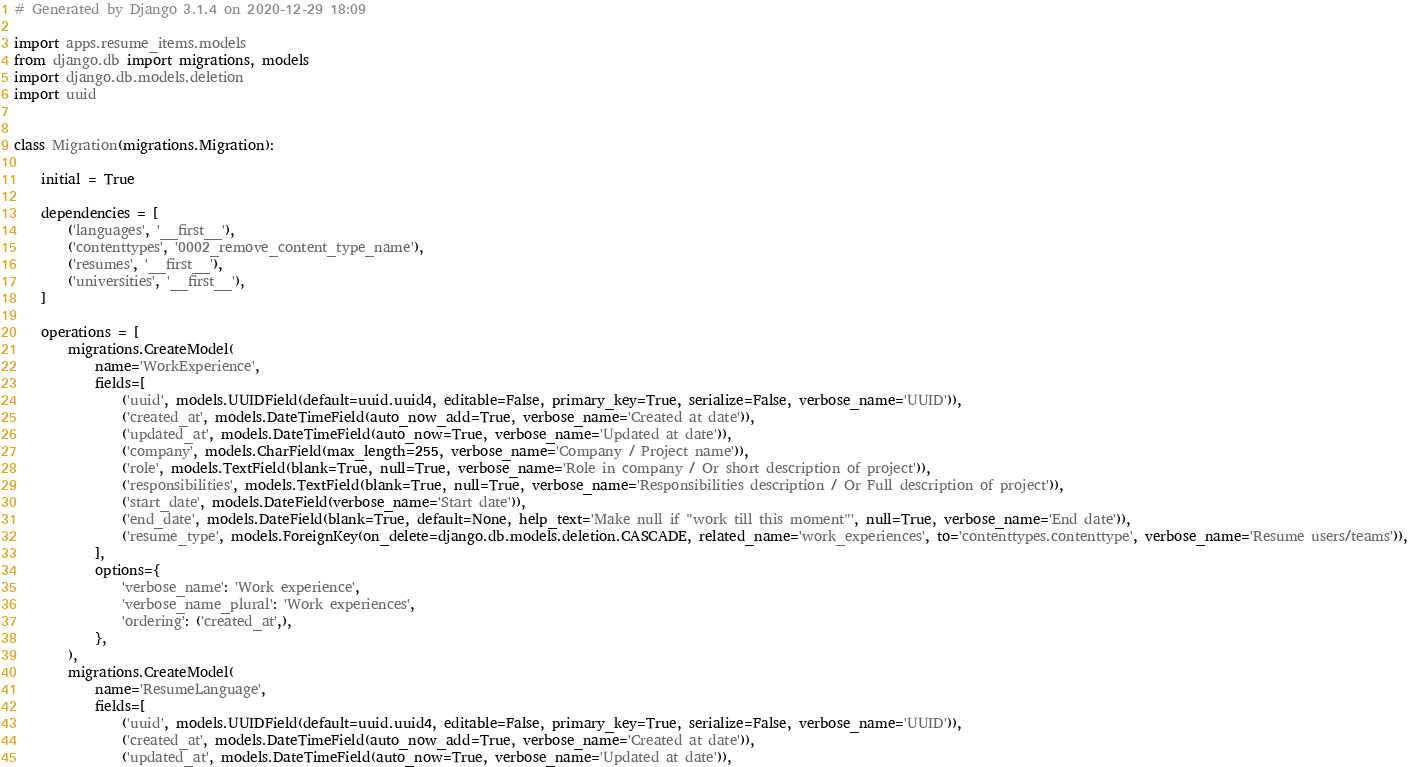Convert code to text. <code><loc_0><loc_0><loc_500><loc_500><_Python_># Generated by Django 3.1.4 on 2020-12-29 18:09

import apps.resume_items.models
from django.db import migrations, models
import django.db.models.deletion
import uuid


class Migration(migrations.Migration):

    initial = True

    dependencies = [
        ('languages', '__first__'),
        ('contenttypes', '0002_remove_content_type_name'),
        ('resumes', '__first__'),
        ('universities', '__first__'),
    ]

    operations = [
        migrations.CreateModel(
            name='WorkExperience',
            fields=[
                ('uuid', models.UUIDField(default=uuid.uuid4, editable=False, primary_key=True, serialize=False, verbose_name='UUID')),
                ('created_at', models.DateTimeField(auto_now_add=True, verbose_name='Created at date')),
                ('updated_at', models.DateTimeField(auto_now=True, verbose_name='Updated at date')),
                ('company', models.CharField(max_length=255, verbose_name='Company / Project name')),
                ('role', models.TextField(blank=True, null=True, verbose_name='Role in company / Or short description of project')),
                ('responsibilities', models.TextField(blank=True, null=True, verbose_name='Responsibilities description / Or Full description of project')),
                ('start_date', models.DateField(verbose_name='Start date')),
                ('end_date', models.DateField(blank=True, default=None, help_text='Make null if "work till this moment"', null=True, verbose_name='End date')),
                ('resume_type', models.ForeignKey(on_delete=django.db.models.deletion.CASCADE, related_name='work_experiences', to='contenttypes.contenttype', verbose_name='Resume users/teams')),
            ],
            options={
                'verbose_name': 'Work experience',
                'verbose_name_plural': 'Work experiences',
                'ordering': ('created_at',),
            },
        ),
        migrations.CreateModel(
            name='ResumeLanguage',
            fields=[
                ('uuid', models.UUIDField(default=uuid.uuid4, editable=False, primary_key=True, serialize=False, verbose_name='UUID')),
                ('created_at', models.DateTimeField(auto_now_add=True, verbose_name='Created at date')),
                ('updated_at', models.DateTimeField(auto_now=True, verbose_name='Updated at date')),</code> 